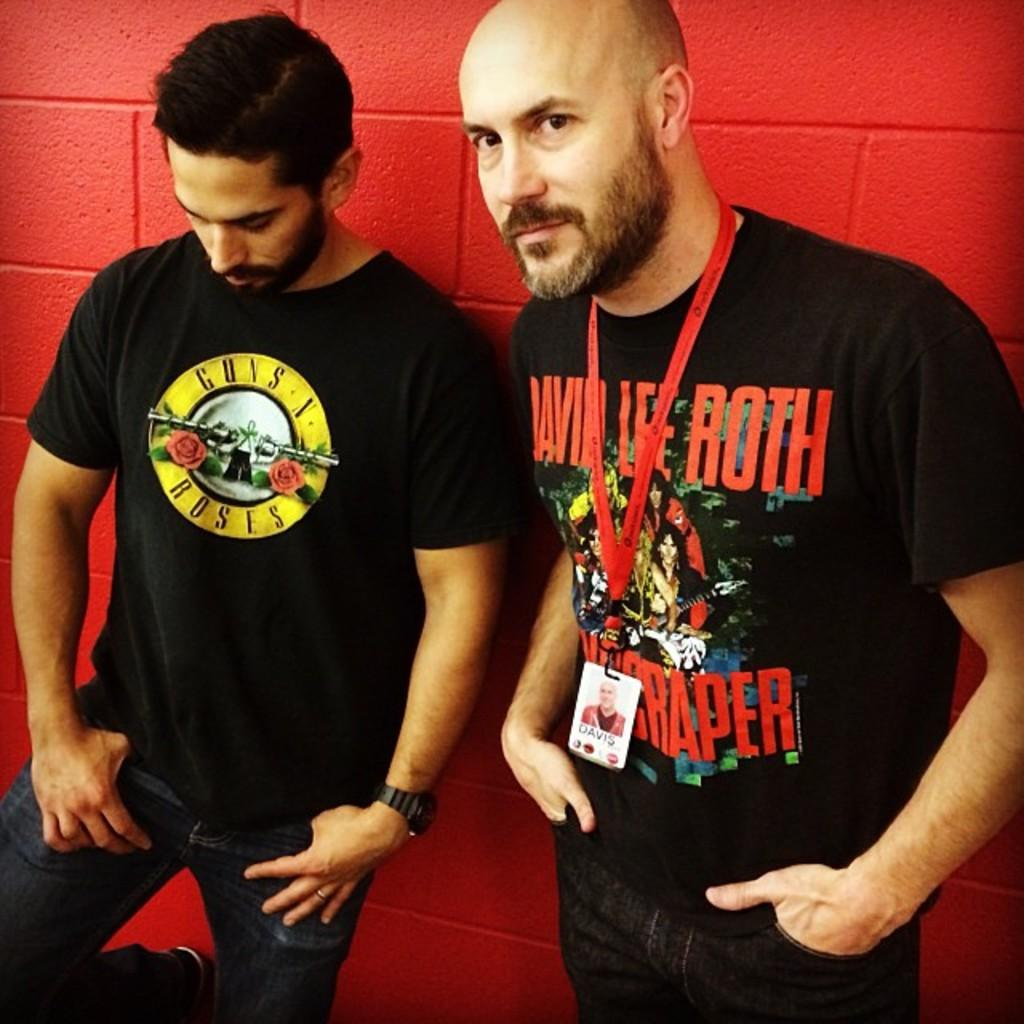<image>
Give a short and clear explanation of the subsequent image. A man with a Guns N Roses t-shirt stand next to another man. 